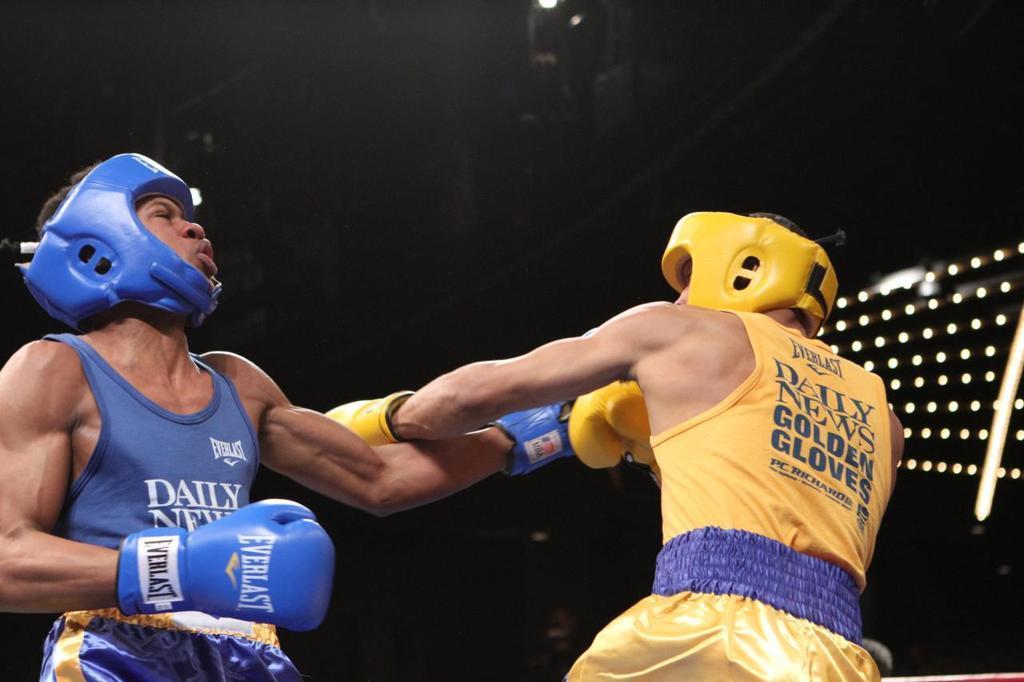Can you describe this image briefly? In this image, there are two persons wearing helmets and playing boxing. 